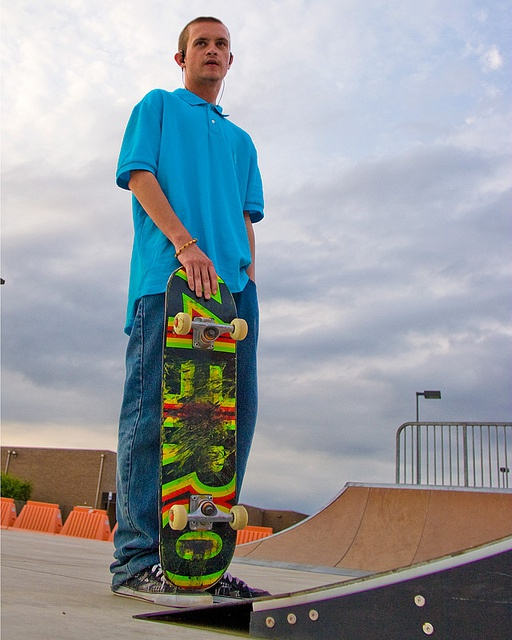Describe the objects in this image and their specific colors. I can see people in white, teal, and darkblue tones and skateboard in white, black, darkgreen, olive, and green tones in this image. 